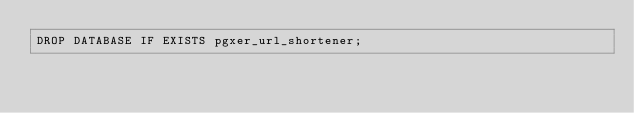Convert code to text. <code><loc_0><loc_0><loc_500><loc_500><_SQL_>DROP DATABASE IF EXISTS pgxer_url_shortener;
</code> 